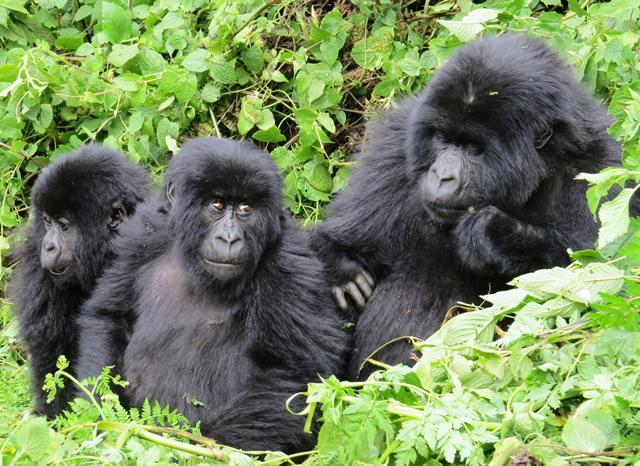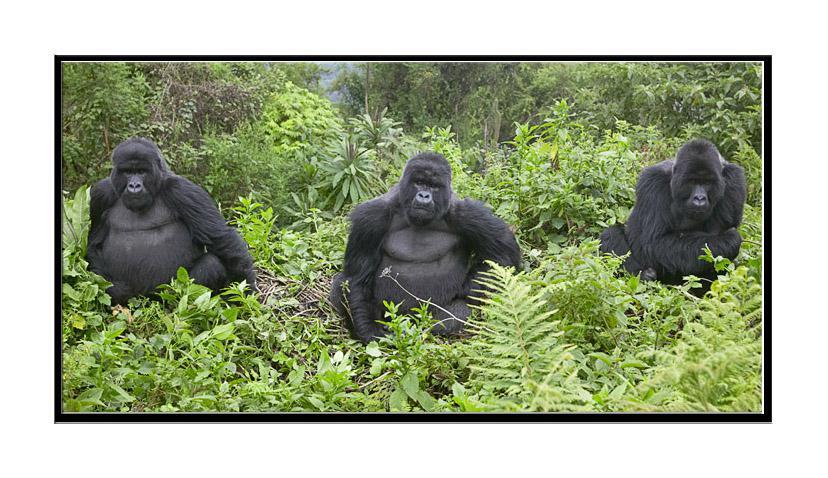The first image is the image on the left, the second image is the image on the right. Evaluate the accuracy of this statement regarding the images: "There are six gorillas tht are sitting". Is it true? Answer yes or no. Yes. The first image is the image on the left, the second image is the image on the right. Examine the images to the left and right. Is the description "The left and right image contains the same number of real breathing gorillas." accurate? Answer yes or no. Yes. 